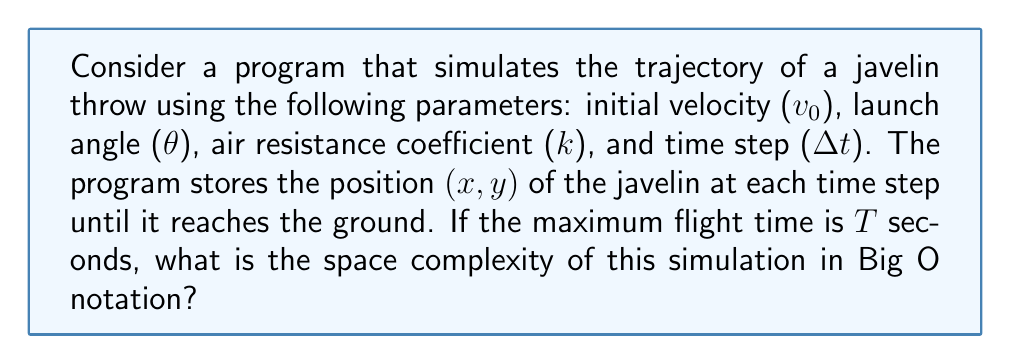Give your solution to this math problem. To analyze the space complexity, we need to consider the amount of memory used by the program:

1. Input variables:
   - $v_0$, $\theta$, $k$, and $\Delta t$ are single values, each using constant space.

2. Time variable:
   - Current time $t$ is a single value, using constant space.

3. Position storage:
   - The program stores $(x, y)$ coordinates at each time step.
   - The number of time steps is $\frac{T}{\Delta t}$, where $T$ is the maximum flight time.
   - Each coordinate pair requires two values (x and y).

4. Additional variables:
   - Temporary variables for calculations use constant space.

The dominant factor in space usage is the storage of position coordinates. The number of stored positions is directly proportional to the number of time steps.

Number of time steps = $\frac{T}{\Delta t}$

Each time step stores two values (x and y), so the total number of stored values is:

$$2 \cdot \frac{T}{\Delta t}$$

Since $T$ and $\Delta t$ are input parameters, we can consider $n = \frac{T}{\Delta t}$ as the input size for our complexity analysis.

Therefore, the space complexity is $O(n)$, where $n$ is the number of time steps in the simulation.
Answer: The space complexity of the javelin throw trajectory simulation program is $O(n)$, where $n$ is the number of time steps in the simulation. 